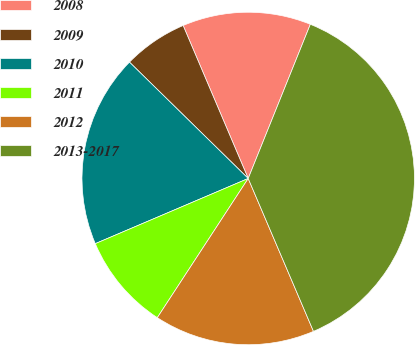Convert chart to OTSL. <chart><loc_0><loc_0><loc_500><loc_500><pie_chart><fcel>2008<fcel>2009<fcel>2010<fcel>2011<fcel>2012<fcel>2013-2017<nl><fcel>12.5%<fcel>6.26%<fcel>18.75%<fcel>9.38%<fcel>15.63%<fcel>37.48%<nl></chart> 